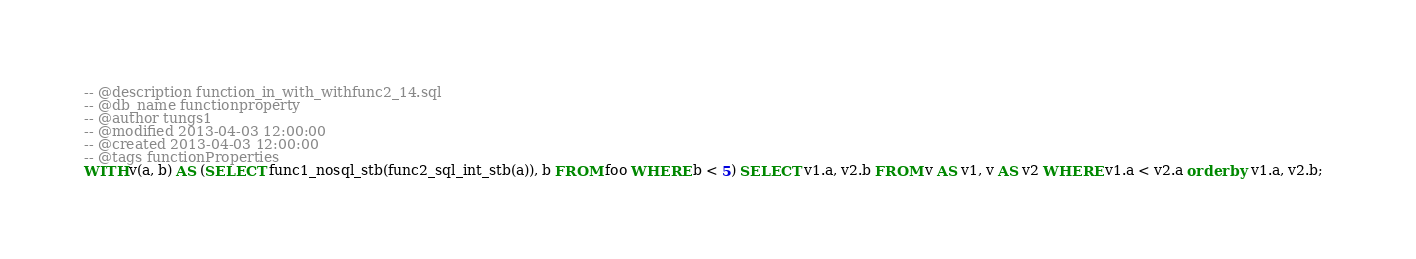Convert code to text. <code><loc_0><loc_0><loc_500><loc_500><_SQL_>-- @description function_in_with_withfunc2_14.sql
-- @db_name functionproperty
-- @author tungs1
-- @modified 2013-04-03 12:00:00
-- @created 2013-04-03 12:00:00
-- @tags functionProperties 
WITH v(a, b) AS (SELECT func1_nosql_stb(func2_sql_int_stb(a)), b FROM foo WHERE b < 5) SELECT v1.a, v2.b FROM v AS v1, v AS v2 WHERE v1.a < v2.a order by v1.a, v2.b;  
</code> 